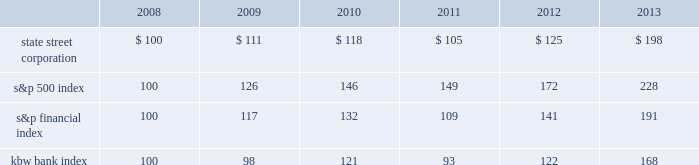Shareholder return performance presentation the graph presented below compares the cumulative total shareholder return on state street's common stock to the cumulative total return of the s&p 500 index , the s&p financial index and the kbw bank index over a five- year period .
The cumulative total shareholder return assumes the investment of $ 100 in state street common stock and in each index on december 31 , 2008 at the closing price on the last trading day of 2008 , and also assumes reinvestment of common stock dividends .
The s&p financial index is a publicly available measure of 81 of the standard & poor's 500 companies , representing 17 diversified financial services companies , 22 insurance companies , 19 real estate companies and 23 banking companies .
The kbw bank index seeks to reflect the performance of banks and thrifts that are publicly traded in the u.s. , and is composed of 24 leading national money center and regional banks and thrifts. .

What is the roi of an investment in kbw bank index from 2008 to 2011? 
Computations: ((93 - 100) / 100)
Answer: -0.07. 